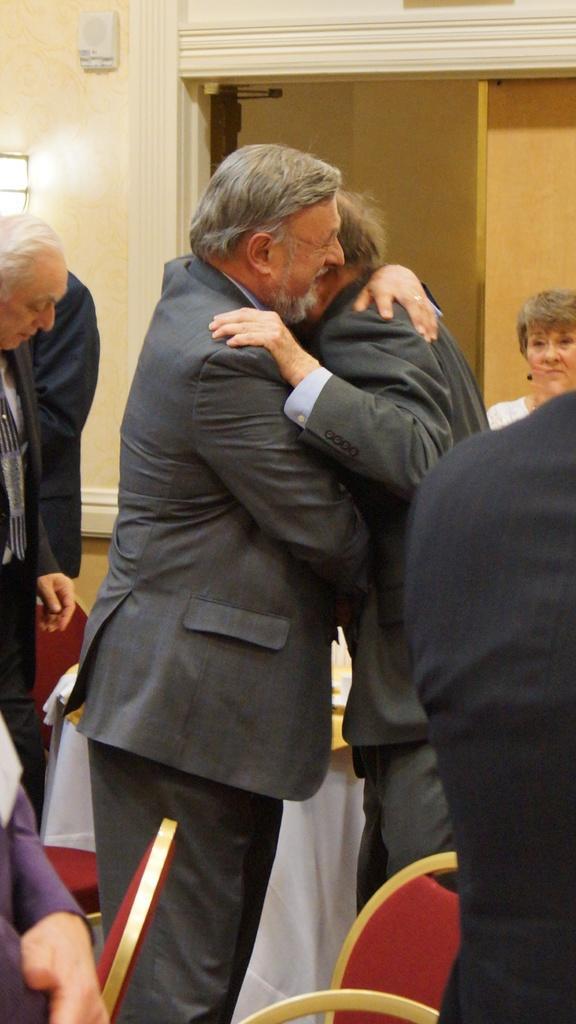Could you give a brief overview of what you see in this image? In the picture we can see people, there are two men standing and hugging each other, there may be a light on the wall, there are chairs. 